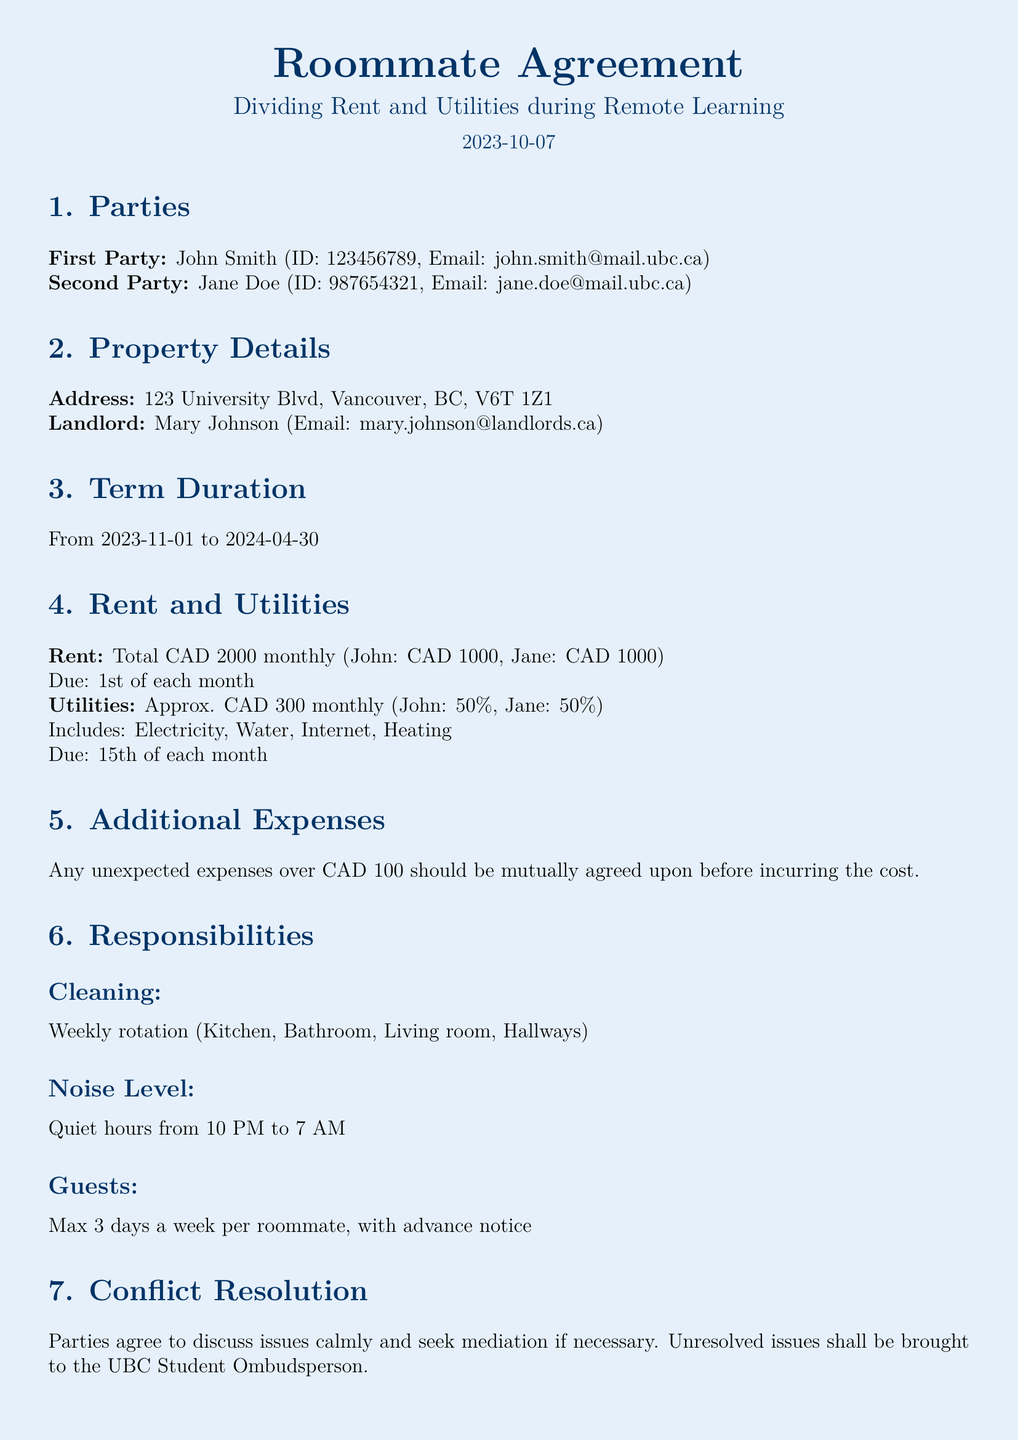What is the name of the first party? The first party is explicitly identified in the document by the name provided at the beginning.
Answer: John Smith What is the total monthly rent amount? The total monthly rent amount is specified in the document under the Rent section, which provides the collective sum to be paid.
Answer: CAD 2000 What is the utility cost percentage each party is responsible for? The document outlines the responsibilities for utilities, indicating how each party is to contribute to the costs.
Answer: 50% What is the maximum number of guests allowed per week? The guest policy in the agreement specifies the limit for visitation by friends and family.
Answer: 3 days What is the written termination notice period? The document provides information regarding termination, including the necessary advance notification in writing.
Answer: 30 days Who is the landlord? The landlord's name and contact information are included in the property details section of the document.
Answer: Mary Johnson What are the agreed quiet hours? The agreement includes guidelines on noise levels, specifying the designated quiet hours for the shared living space.
Answer: 10 PM to 7 AM What should be done if unexpected expenses exceed CAD 100? The agreement addresses how unexpected costs should be handled between the parties, focusing on communication before incurring any expense.
Answer: Mutually agreed upon What is the date of the document? The document was created on a specific date, mentioned prominently at the beginning of the agreement.
Answer: 2023-10-07 